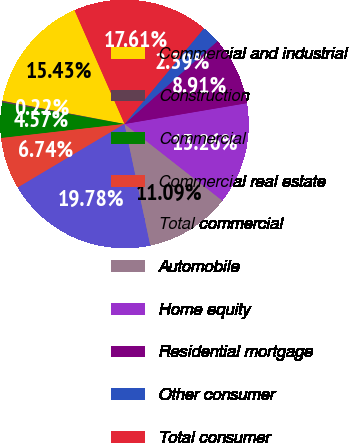Convert chart to OTSL. <chart><loc_0><loc_0><loc_500><loc_500><pie_chart><fcel>Commercial and industrial<fcel>Construction<fcel>Commercial<fcel>Commercial real estate<fcel>Total commercial<fcel>Automobile<fcel>Home equity<fcel>Residential mortgage<fcel>Other consumer<fcel>Total consumer<nl><fcel>15.43%<fcel>0.22%<fcel>4.57%<fcel>6.74%<fcel>19.78%<fcel>11.09%<fcel>13.26%<fcel>8.91%<fcel>2.39%<fcel>17.61%<nl></chart> 